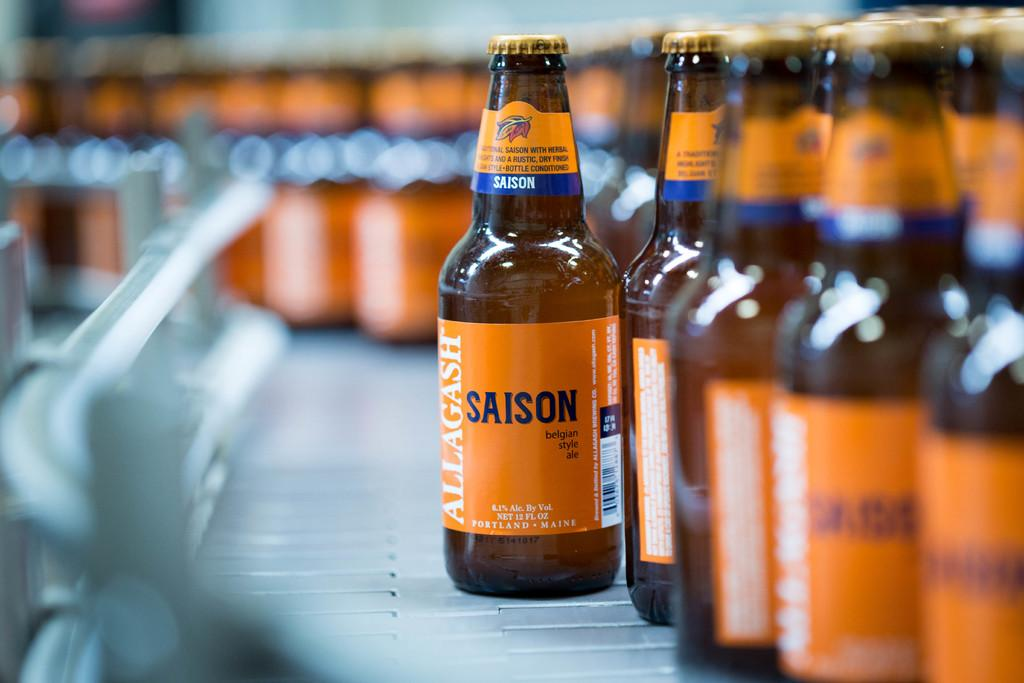What color are the bottles in the image? The bottles in the image are orange in color. How are the bottles arranged in the image? The bottles are arranged in a metal stand. Where is the metal stand located in the image? The metal stand is on the right side of the image. What type of bun can be seen on the road in the image? There is no bun or road present in the image; it only features orange color bottles arranged in a metal stand. 